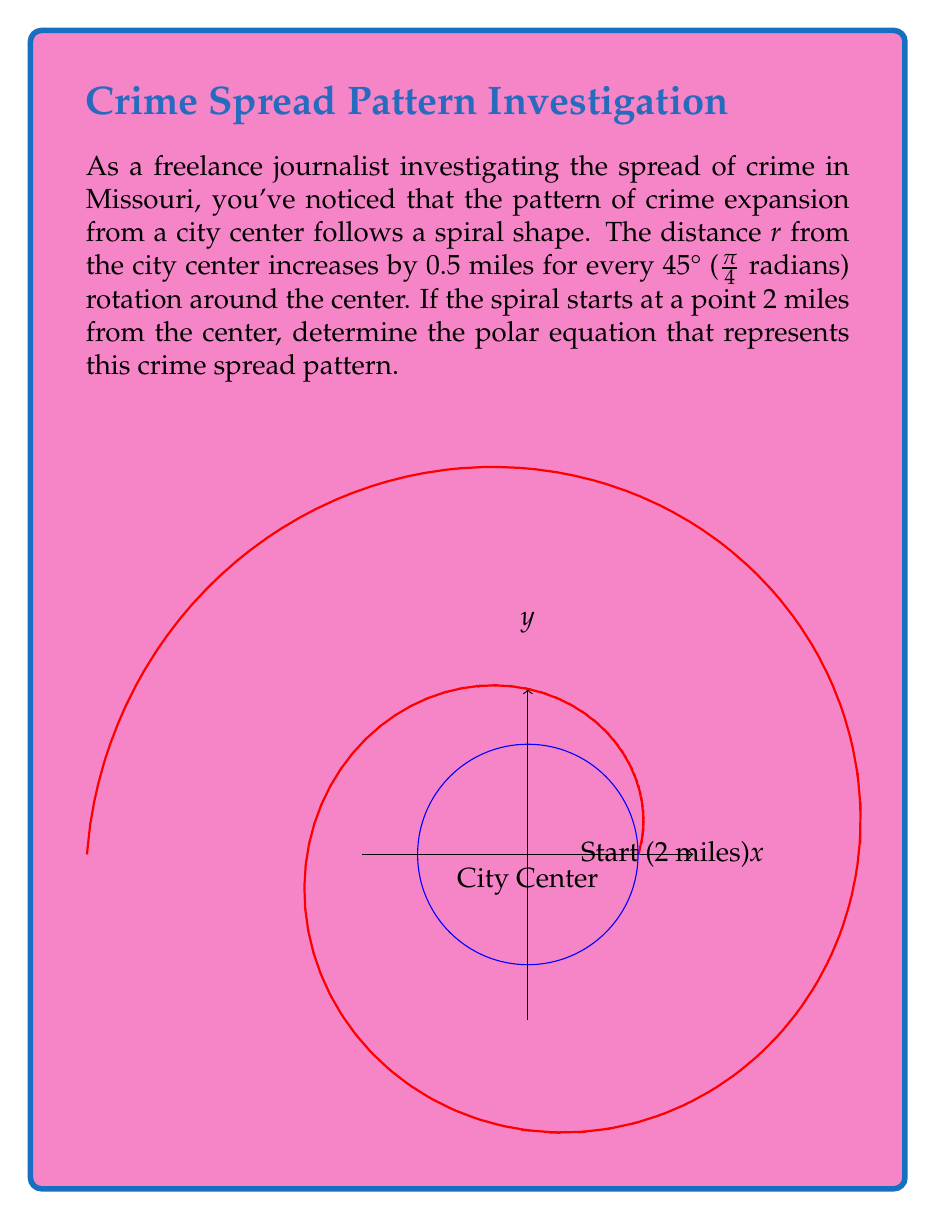Help me with this question. Let's approach this step-by-step:

1) In a polar equation of a spiral, the general form is:

   $r = a + b\theta$

   where $a$ is the starting distance and $b$ is the rate of increase per radian.

2) We're given that the spiral starts at 2 miles from the center, so $a = 2$.

3) To find $b$, we need to determine the rate of increase per radian:
   - The distance increases by 0.5 miles every 45° (π/4 radians)
   - So, $b = \frac{0.5}{\pi/4} = \frac{2}{\pi}$

4) Substituting these values into the general form:

   $r = 2 + \frac{2}{\pi}\theta$

5) This equation represents the spiral pattern of crime spread, where:
   - $r$ is the distance from the city center in miles
   - $\theta$ is the angle of rotation in radians
   - The spiral starts 2 miles from the center and increases by $\frac{2}{\pi}$ miles per radian
Answer: $r = 2 + \frac{2}{\pi}\theta$ 